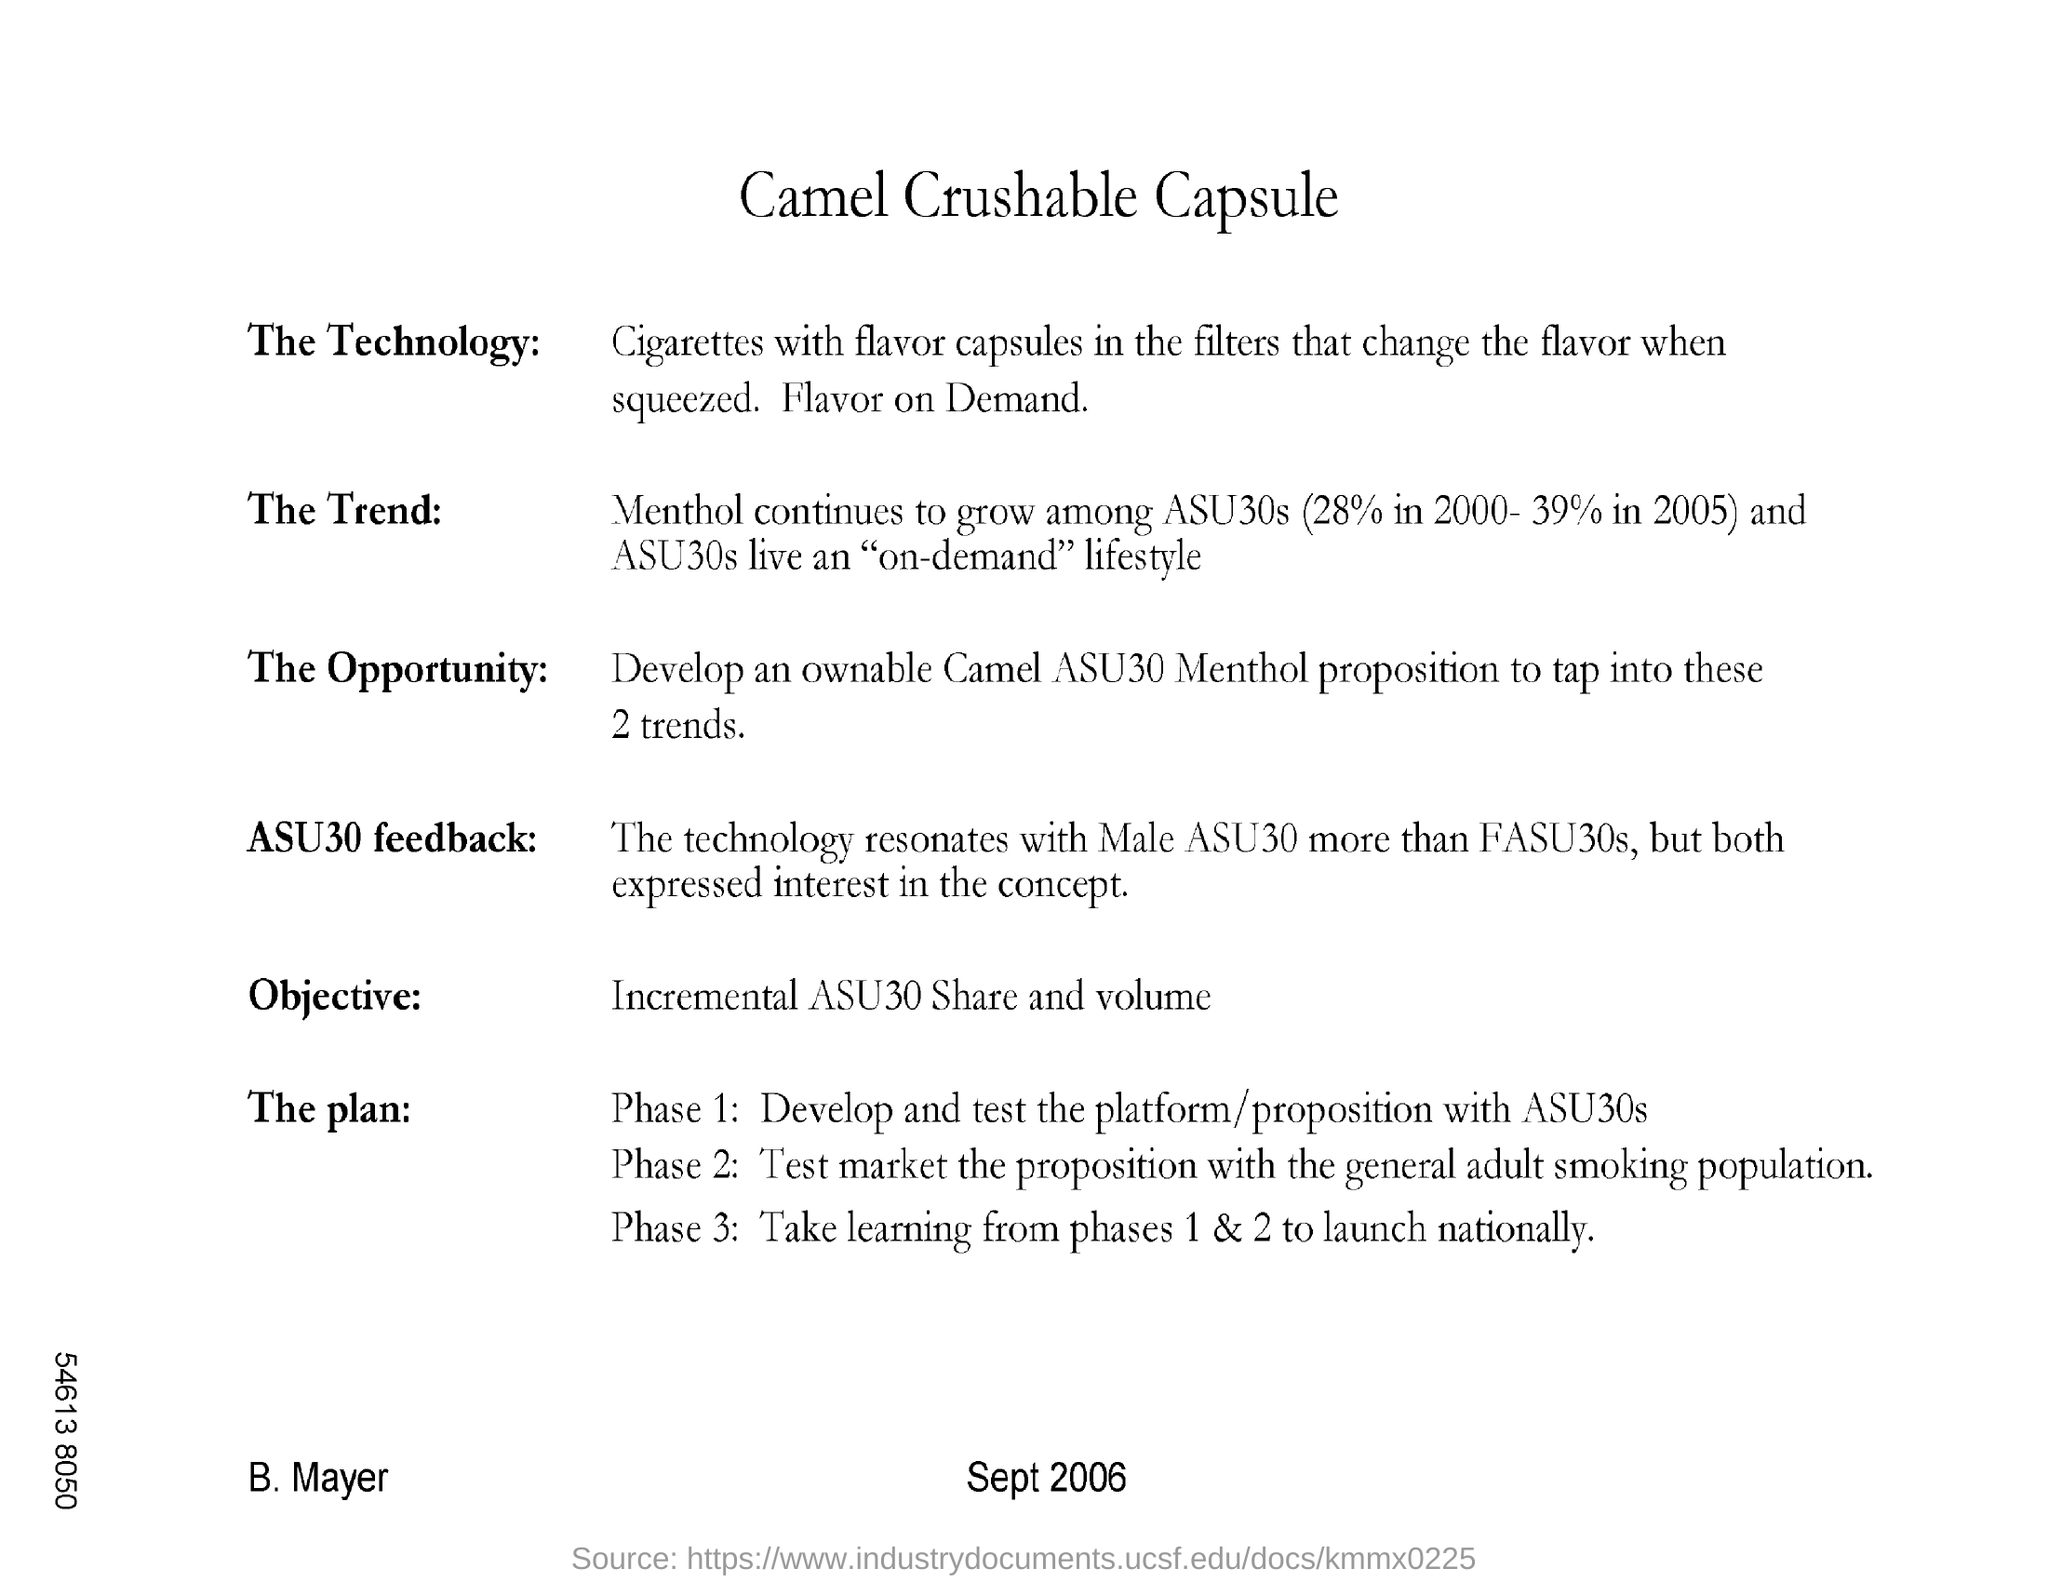What is inside the filters that change the flavor when squeezed?
Offer a very short reply. Flavor capsules. What is the menthol % in 2000?
Keep it short and to the point. 28%. What is the "objective"?
Ensure brevity in your answer.  Incremental asu30 share and volume. How many Phases does the plan divided into?
Ensure brevity in your answer.  3. Mention the Phase  in which marketing the product is involved?
Your response must be concise. Phase 2. What live an "on-demand" lifestyle?
Provide a succinct answer. ASU30s. What is Phase 3 mainly about?
Ensure brevity in your answer.  Take learning from phases 1& 2 to lunch nationally. 